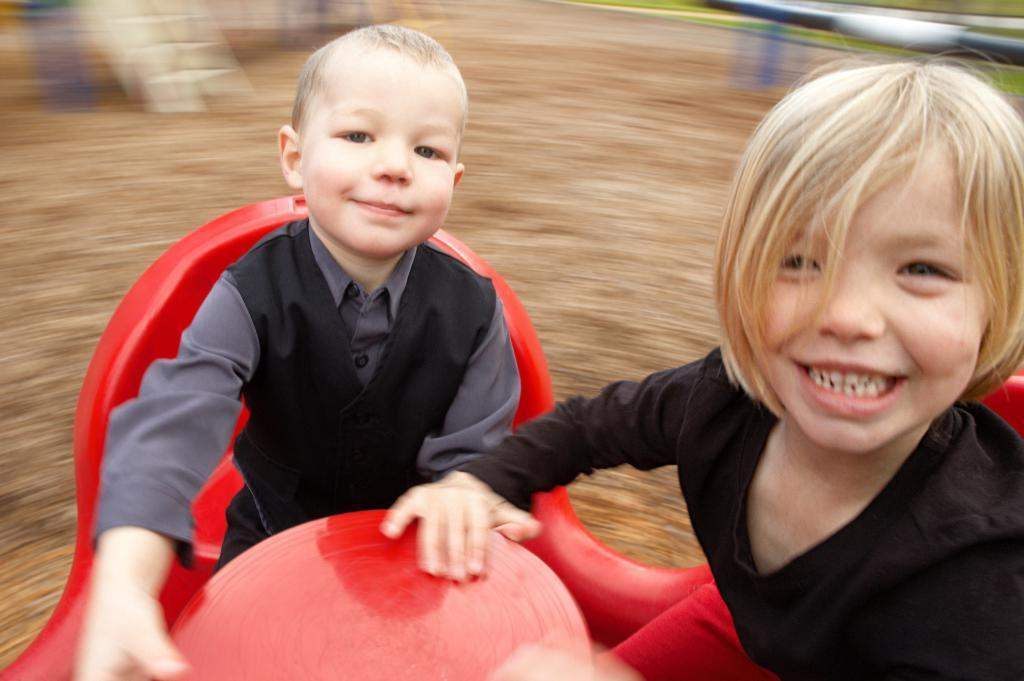How many people are in the image? There are two people in the image. What are the people doing in the image? The people are smiling in the image. What are the people sitting on in the image? The people are sitting on an object in the image. What can be seen in the background of the image? There are objects visible in the background of the image. How would you describe the background of the image? The background of the image is blurry. What is the purpose of the wound on the grandfather's arm in the image? There is no mention of a wound or a grandfather in the image, so this question cannot be answered. 